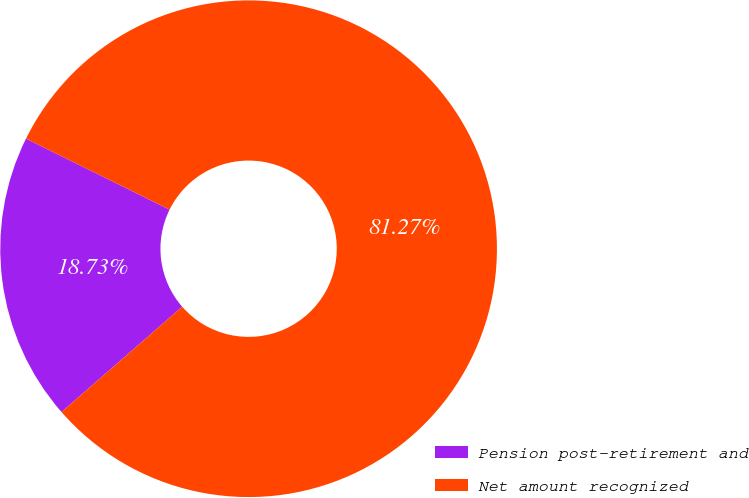Convert chart. <chart><loc_0><loc_0><loc_500><loc_500><pie_chart><fcel>Pension post-retirement and<fcel>Net amount recognized<nl><fcel>18.73%<fcel>81.27%<nl></chart> 